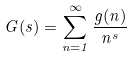<formula> <loc_0><loc_0><loc_500><loc_500>G ( s ) = \sum _ { n = 1 } ^ { \infty } \frac { g ( n ) } { n ^ { s } }</formula> 